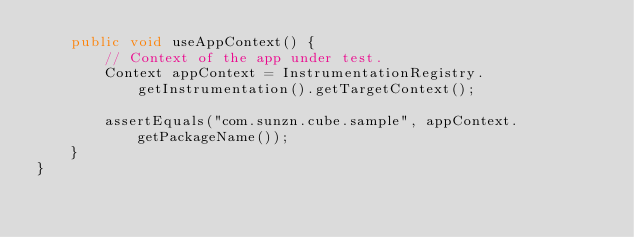Convert code to text. <code><loc_0><loc_0><loc_500><loc_500><_Java_>    public void useAppContext() {
        // Context of the app under test.
        Context appContext = InstrumentationRegistry.getInstrumentation().getTargetContext();

        assertEquals("com.sunzn.cube.sample", appContext.getPackageName());
    }
}
</code> 